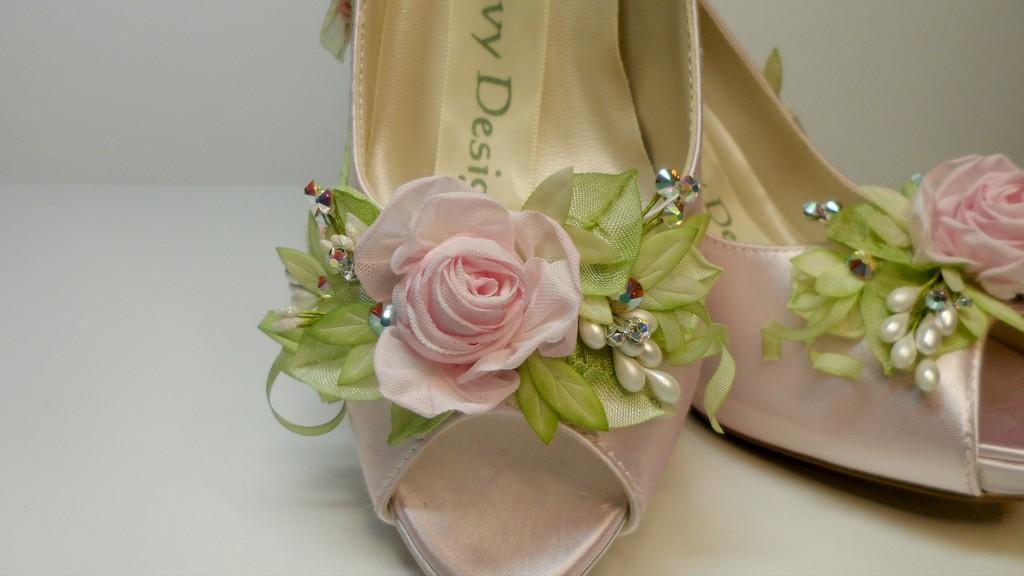Can you describe this image briefly? In this picture we can see a pair of heels and on the heels there are pearls and there are artificial flowers and leaves. Behind the heels, there is the white background. 